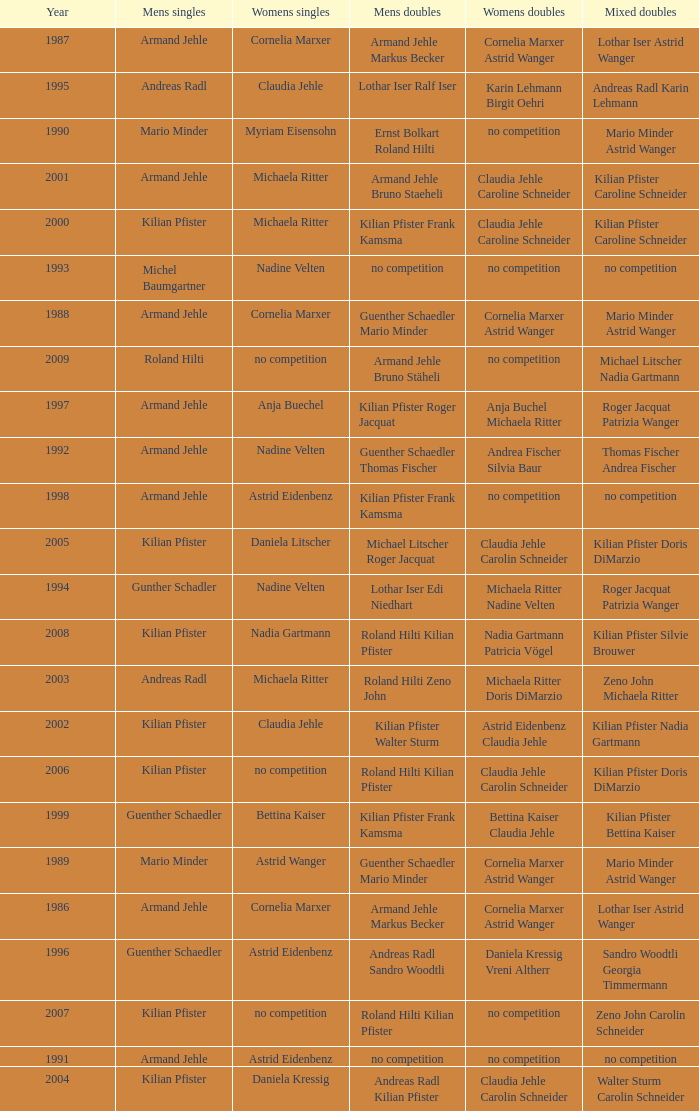In 2001, where the mens singles is armand jehle and the womens singles is michaela ritter, who are the mixed doubles Kilian Pfister Caroline Schneider. 